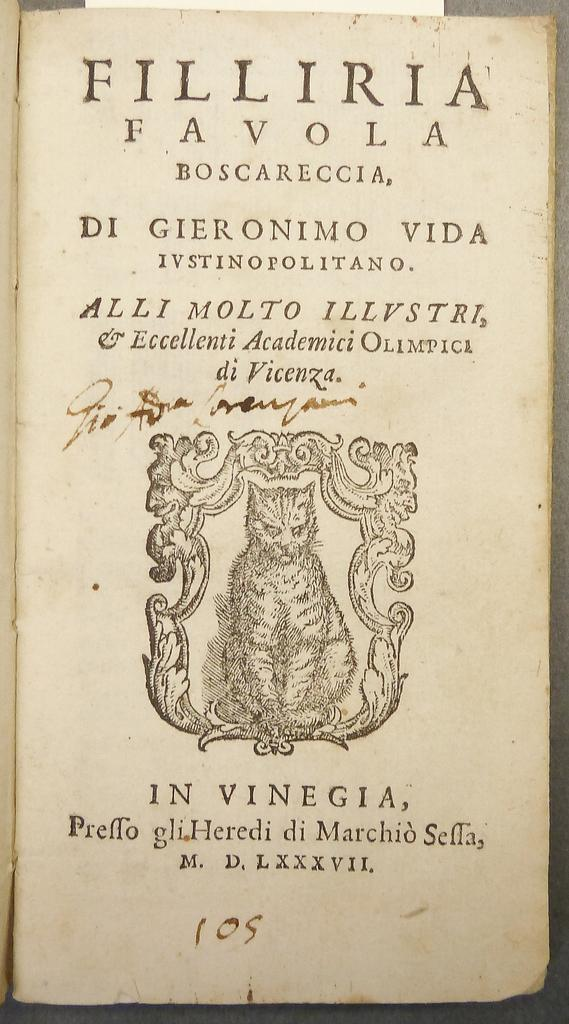What is the main object in the image? There is a white paper in the image. What is on the white paper? There is text written on the paper. Is there any drawing on the white paper? Yes, there is a sketch of a cat in the image. How many islands can be seen in the sketch of the cat? There are no islands present in the image, as it features a white paper with text and a sketch of a cat. 